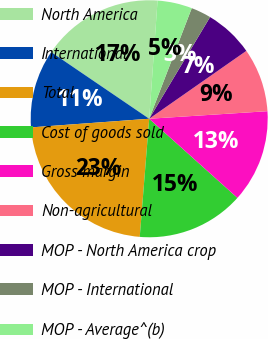<chart> <loc_0><loc_0><loc_500><loc_500><pie_chart><fcel>North America<fcel>International<fcel>Total<fcel>Cost of goods sold<fcel>Gross margin<fcel>Non-agricultural<fcel>MOP - North America crop<fcel>MOP - International<fcel>MOP - Average^(b)<nl><fcel>16.62%<fcel>10.67%<fcel>22.57%<fcel>14.64%<fcel>12.65%<fcel>8.69%<fcel>6.71%<fcel>2.74%<fcel>4.72%<nl></chart> 